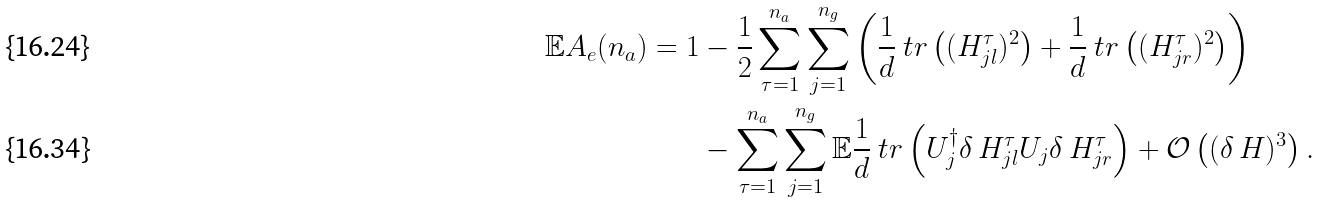<formula> <loc_0><loc_0><loc_500><loc_500>\mathbb { E } A _ { e } ( n _ { a } ) = 1 & - \frac { 1 } { 2 } \sum _ { \tau = 1 } ^ { n _ { a } } \sum _ { j = 1 } ^ { n _ { g } } \left ( \frac { 1 } { d } \ t r \left ( ( H _ { j l } ^ { \tau } ) ^ { 2 } \right ) + \frac { 1 } { d } \ t r \left ( ( H _ { j r } ^ { \tau } ) ^ { 2 } \right ) \right ) \\ & - \sum _ { \tau = 1 } ^ { n _ { a } } \sum _ { j = 1 } ^ { n _ { g } } \mathbb { E } \frac { 1 } { d } \ t r \left ( U ^ { \dagger } _ { j } \delta \, H _ { j l } ^ { \tau } U _ { j } \delta \, H _ { j r } ^ { \tau } \right ) + \mathcal { O } \left ( ( \delta \, H ) ^ { 3 } \right ) .</formula> 